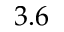Convert formula to latex. <formula><loc_0><loc_0><loc_500><loc_500>3 . 6</formula> 